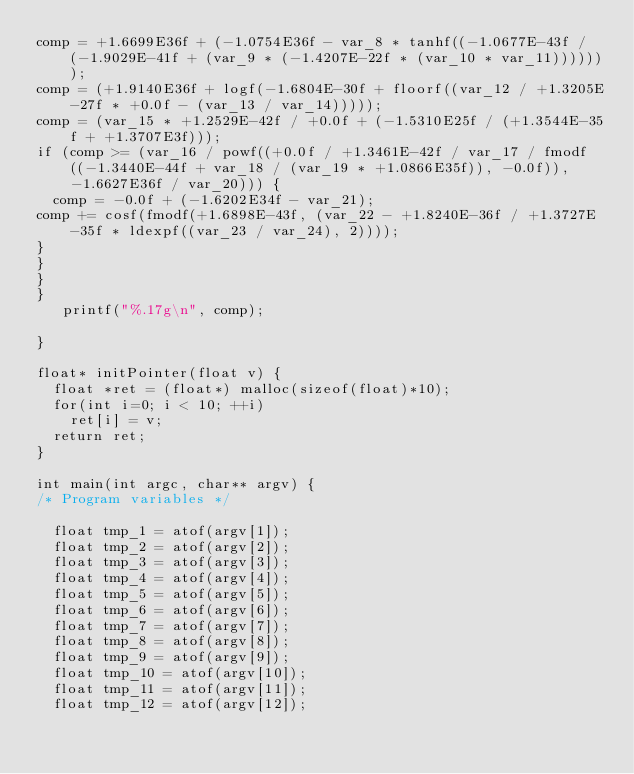Convert code to text. <code><loc_0><loc_0><loc_500><loc_500><_Cuda_>comp = +1.6699E36f + (-1.0754E36f - var_8 * tanhf((-1.0677E-43f / (-1.9029E-41f + (var_9 * (-1.4207E-22f * (var_10 * var_11)))))));
comp = (+1.9140E36f + logf(-1.6804E-30f + floorf((var_12 / +1.3205E-27f * +0.0f - (var_13 / var_14)))));
comp = (var_15 * +1.2529E-42f / +0.0f + (-1.5310E25f / (+1.3544E-35f + +1.3707E3f)));
if (comp >= (var_16 / powf((+0.0f / +1.3461E-42f / var_17 / fmodf((-1.3440E-44f + var_18 / (var_19 * +1.0866E35f)), -0.0f)), -1.6627E36f / var_20))) {
  comp = -0.0f + (-1.6202E34f - var_21);
comp += cosf(fmodf(+1.6898E-43f, (var_22 - +1.8240E-36f / +1.3727E-35f * ldexpf((var_23 / var_24), 2))));
}
}
}
}
   printf("%.17g\n", comp);

}

float* initPointer(float v) {
  float *ret = (float*) malloc(sizeof(float)*10);
  for(int i=0; i < 10; ++i)
    ret[i] = v;
  return ret;
}

int main(int argc, char** argv) {
/* Program variables */

  float tmp_1 = atof(argv[1]);
  float tmp_2 = atof(argv[2]);
  float tmp_3 = atof(argv[3]);
  float tmp_4 = atof(argv[4]);
  float tmp_5 = atof(argv[5]);
  float tmp_6 = atof(argv[6]);
  float tmp_7 = atof(argv[7]);
  float tmp_8 = atof(argv[8]);
  float tmp_9 = atof(argv[9]);
  float tmp_10 = atof(argv[10]);
  float tmp_11 = atof(argv[11]);
  float tmp_12 = atof(argv[12]);</code> 